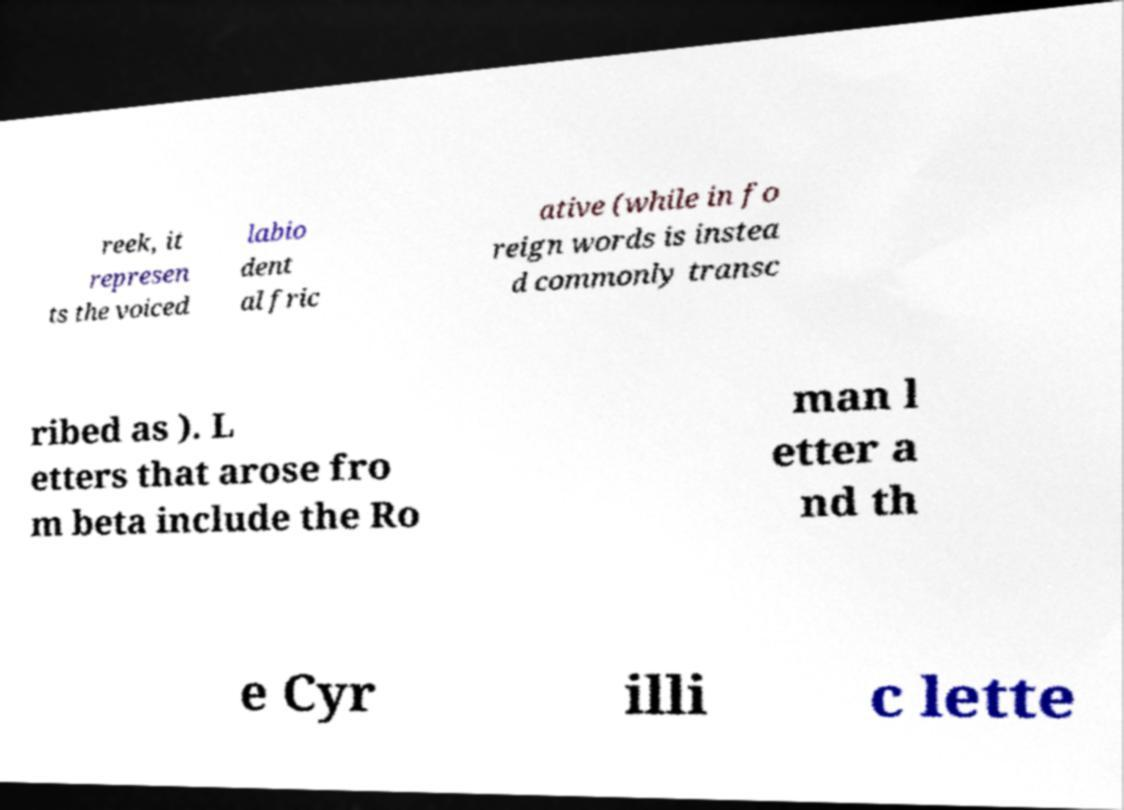Could you assist in decoding the text presented in this image and type it out clearly? reek, it represen ts the voiced labio dent al fric ative (while in fo reign words is instea d commonly transc ribed as ). L etters that arose fro m beta include the Ro man l etter a nd th e Cyr illi c lette 